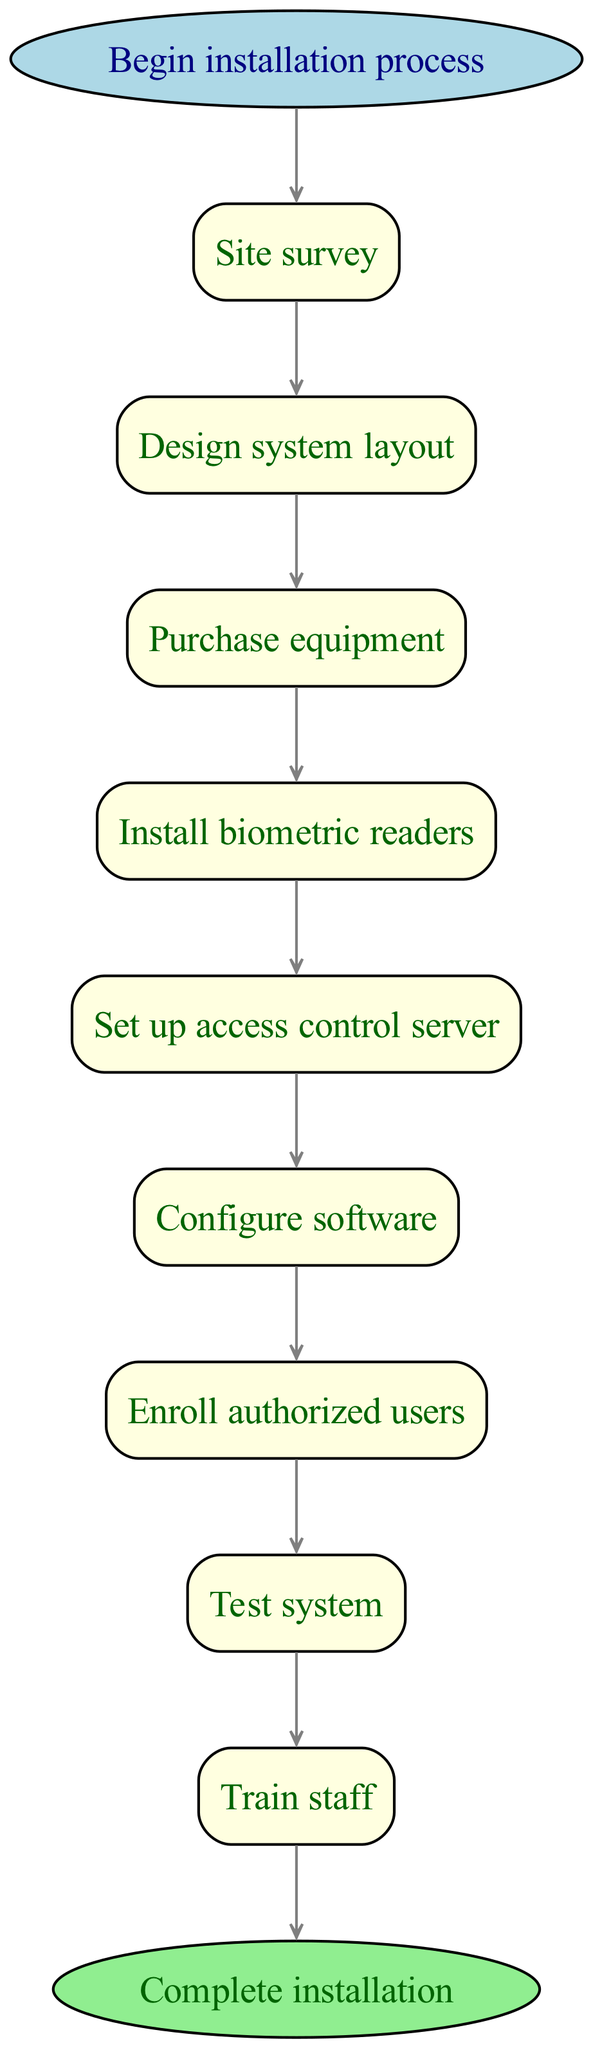What is the first step in the installation process? The diagram indicates the first step is labeled "Site survey," which is directly connected to the "Begin installation process" node.
Answer: Site survey How many steps are involved in the process? By counting the steps listed in the diagram, there are a total of 9 distinct steps from "Site survey" to "Train staff."
Answer: 9 What is the last action before the system is activated? Referring to the diagram, the step that directly precedes "Activate system" is "Train staff," showing the flow of the process.
Answer: Train staff Which step follows the "Enroll authorized users"? According to the diagram, the next step after "Enroll authorized users" is "Test system," which is indicated by the directional arrow from one step to the next.
Answer: Test system What type of node marks the beginning of the diagram? The starting point is labeled as "Begin installation process," which is represented as an ellipse shape in the diagram.
Answer: Begin installation process If the "Purchase equipment" step is skipped, what will be the next step? The diagram indicates a direct flow; skipping "Purchase equipment" means proceeding from "Design system layout" to "Install biometric readers," as no other step follows.
Answer: Install biometric readers How many edges connect the steps in the diagram? Each step in the installation process connects with an edge to the next step. With 9 steps, there are 9 edges connecting them (including the start and end).
Answer: 9 What is the shape of the end node in the diagram? The end node, labeled "Complete installation," is represented by an ellipse, similar to the starting node.
Answer: Ellipse What color is the filled shape for the process steps? The diagram shows that the process steps are filled with light yellow color, which is specified for rectangular nodes in the flowchart.
Answer: Light yellow 